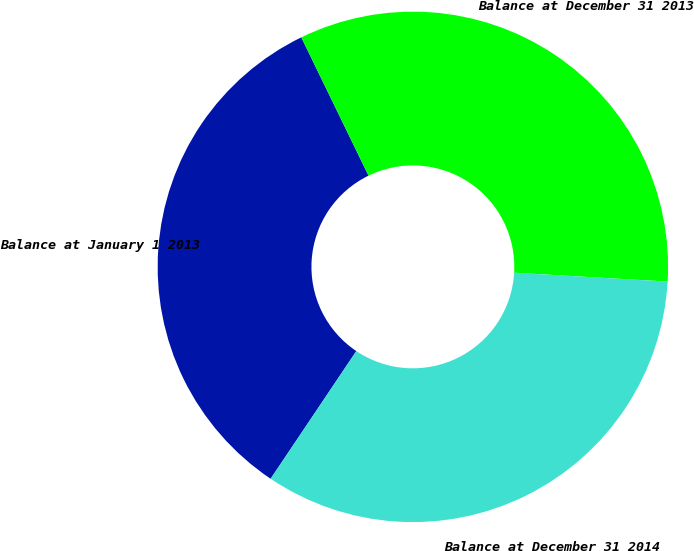<chart> <loc_0><loc_0><loc_500><loc_500><pie_chart><fcel>Balance at January 1 2013<fcel>Balance at December 31 2013<fcel>Balance at December 31 2014<nl><fcel>33.39%<fcel>33.12%<fcel>33.49%<nl></chart> 